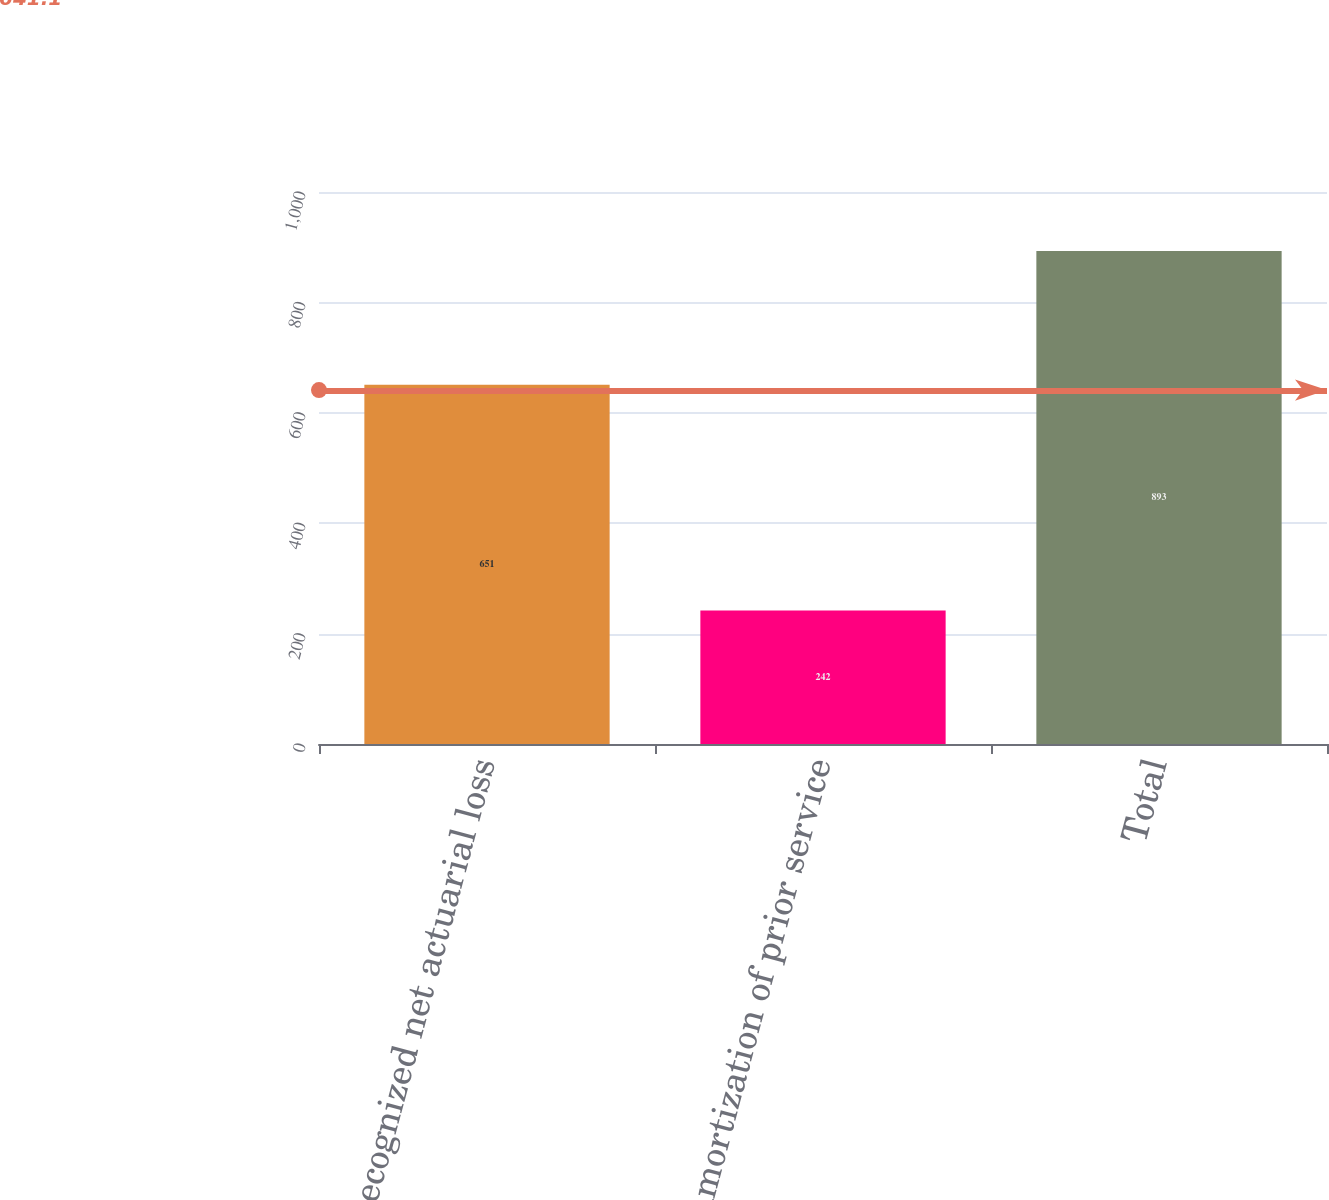<chart> <loc_0><loc_0><loc_500><loc_500><bar_chart><fcel>Recognized net actuarial loss<fcel>Amortization of prior service<fcel>Total<nl><fcel>651<fcel>242<fcel>893<nl></chart> 